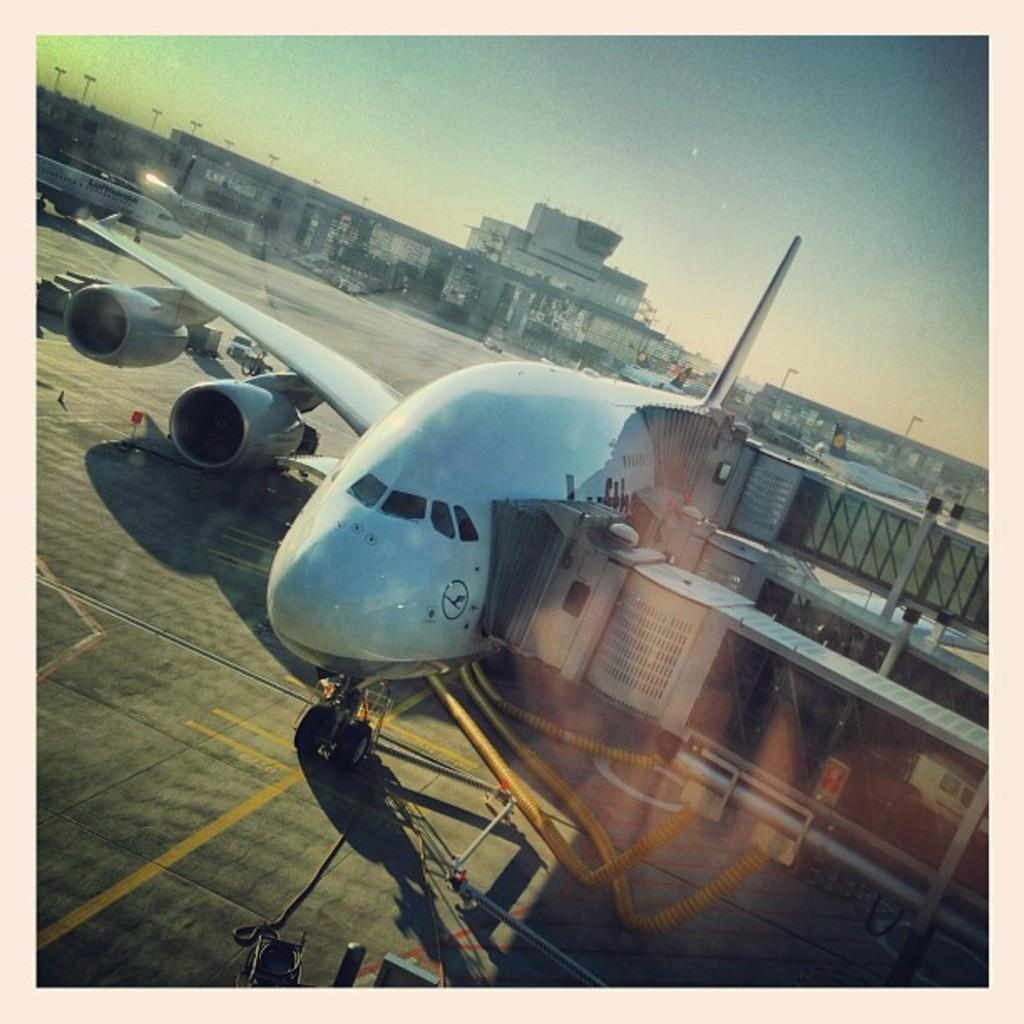What is the main subject of the picture? The main subject of the picture is an aircraft. What can be seen on the right side of the picture? There is a vehicle on the right side of the picture. What is located in the middle of the picture? There is a building in the middle of the picture. How is the building positioned in relation to the aircraft? The building is in front of the aircraft. What are the poles used for in the image? The poles are in front of the building, but their specific purpose is not mentioned in the facts. What is visible at the top of the picture? The sky is visible at the top of the picture. Can you tell me the purpose of the vein in the image? There is no mention of a vein in the image, so it is not possible to determine its purpose. 